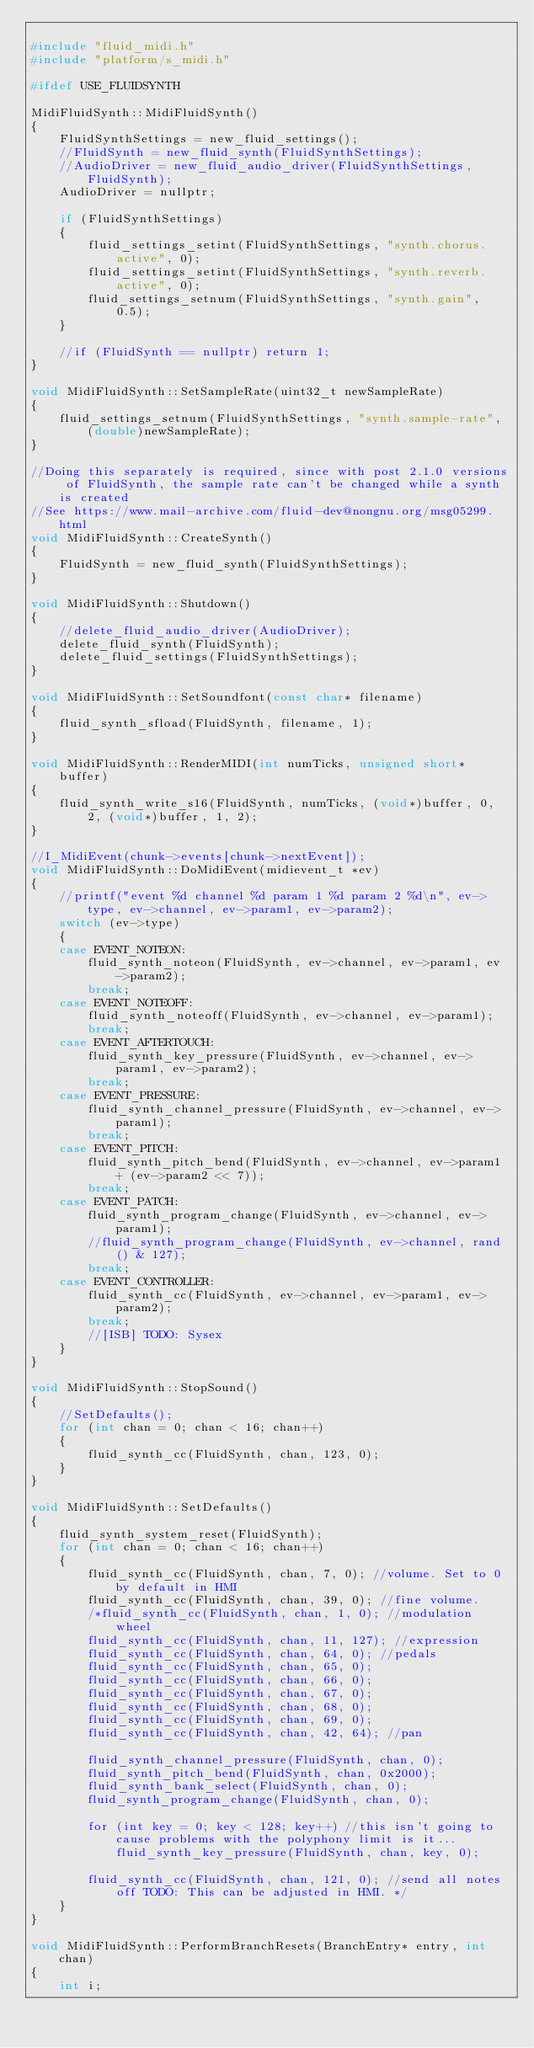<code> <loc_0><loc_0><loc_500><loc_500><_C++_>
#include "fluid_midi.h"
#include "platform/s_midi.h"

#ifdef USE_FLUIDSYNTH

MidiFluidSynth::MidiFluidSynth()
{
	FluidSynthSettings = new_fluid_settings();
	//FluidSynth = new_fluid_synth(FluidSynthSettings);
	//AudioDriver = new_fluid_audio_driver(FluidSynthSettings, FluidSynth);
	AudioDriver = nullptr;

	if (FluidSynthSettings)
	{
		fluid_settings_setint(FluidSynthSettings, "synth.chorus.active", 0);
		fluid_settings_setint(FluidSynthSettings, "synth.reverb.active", 0);
		fluid_settings_setnum(FluidSynthSettings, "synth.gain", 0.5);
	}

	//if (FluidSynth == nullptr) return 1;
}

void MidiFluidSynth::SetSampleRate(uint32_t newSampleRate)
{
	fluid_settings_setnum(FluidSynthSettings, "synth.sample-rate", (double)newSampleRate);
}

//Doing this separately is required, since with post 2.1.0 versions of FluidSynth, the sample rate can't be changed while a synth is created
//See https://www.mail-archive.com/fluid-dev@nongnu.org/msg05299.html
void MidiFluidSynth::CreateSynth()
{
	FluidSynth = new_fluid_synth(FluidSynthSettings);
}

void MidiFluidSynth::Shutdown()
{
	//delete_fluid_audio_driver(AudioDriver);
	delete_fluid_synth(FluidSynth);
	delete_fluid_settings(FluidSynthSettings);
}

void MidiFluidSynth::SetSoundfont(const char* filename)
{
	fluid_synth_sfload(FluidSynth, filename, 1);
}

void MidiFluidSynth::RenderMIDI(int numTicks, unsigned short* buffer)
{
	fluid_synth_write_s16(FluidSynth, numTicks, (void*)buffer, 0, 2, (void*)buffer, 1, 2);
}

//I_MidiEvent(chunk->events[chunk->nextEvent]);
void MidiFluidSynth::DoMidiEvent(midievent_t *ev)
{
	//printf("event %d channel %d param 1 %d param 2 %d\n", ev->type, ev->channel, ev->param1, ev->param2);
	switch (ev->type)
	{
	case EVENT_NOTEON:
		fluid_synth_noteon(FluidSynth, ev->channel, ev->param1, ev->param2);
		break;
	case EVENT_NOTEOFF:
		fluid_synth_noteoff(FluidSynth, ev->channel, ev->param1);
		break;
	case EVENT_AFTERTOUCH:
		fluid_synth_key_pressure(FluidSynth, ev->channel, ev->param1, ev->param2);
		break;
	case EVENT_PRESSURE:
		fluid_synth_channel_pressure(FluidSynth, ev->channel, ev->param1);
		break;
	case EVENT_PITCH:
		fluid_synth_pitch_bend(FluidSynth, ev->channel, ev->param1 + (ev->param2 << 7));
		break;
	case EVENT_PATCH:
		fluid_synth_program_change(FluidSynth, ev->channel, ev->param1);
		//fluid_synth_program_change(FluidSynth, ev->channel, rand() & 127);
		break;
	case EVENT_CONTROLLER:
		fluid_synth_cc(FluidSynth, ev->channel, ev->param1, ev->param2);
		break;
		//[ISB] TODO: Sysex
	}
}

void MidiFluidSynth::StopSound()
{
	//SetDefaults();
	for (int chan = 0; chan < 16; chan++)
	{
		fluid_synth_cc(FluidSynth, chan, 123, 0);
	}
}

void MidiFluidSynth::SetDefaults()
{
	fluid_synth_system_reset(FluidSynth);
	for (int chan = 0; chan < 16; chan++)
	{
		fluid_synth_cc(FluidSynth, chan, 7, 0); //volume. Set to 0 by default in HMI
		fluid_synth_cc(FluidSynth, chan, 39, 0); //fine volume.
		/*fluid_synth_cc(FluidSynth, chan, 1, 0); //modulation wheel
		fluid_synth_cc(FluidSynth, chan, 11, 127); //expression
		fluid_synth_cc(FluidSynth, chan, 64, 0); //pedals
		fluid_synth_cc(FluidSynth, chan, 65, 0);
		fluid_synth_cc(FluidSynth, chan, 66, 0);
		fluid_synth_cc(FluidSynth, chan, 67, 0);
		fluid_synth_cc(FluidSynth, chan, 68, 0);
		fluid_synth_cc(FluidSynth, chan, 69, 0);
		fluid_synth_cc(FluidSynth, chan, 42, 64); //pan

		fluid_synth_channel_pressure(FluidSynth, chan, 0);
		fluid_synth_pitch_bend(FluidSynth, chan, 0x2000);
		fluid_synth_bank_select(FluidSynth, chan, 0);
		fluid_synth_program_change(FluidSynth, chan, 0);

		for (int key = 0; key < 128; key++) //this isn't going to cause problems with the polyphony limit is it...
			fluid_synth_key_pressure(FluidSynth, chan, key, 0);

		fluid_synth_cc(FluidSynth, chan, 121, 0); //send all notes off TODO: This can be adjusted in HMI. */
	}
}

void MidiFluidSynth::PerformBranchResets(BranchEntry* entry, int chan)
{
	int i;</code> 